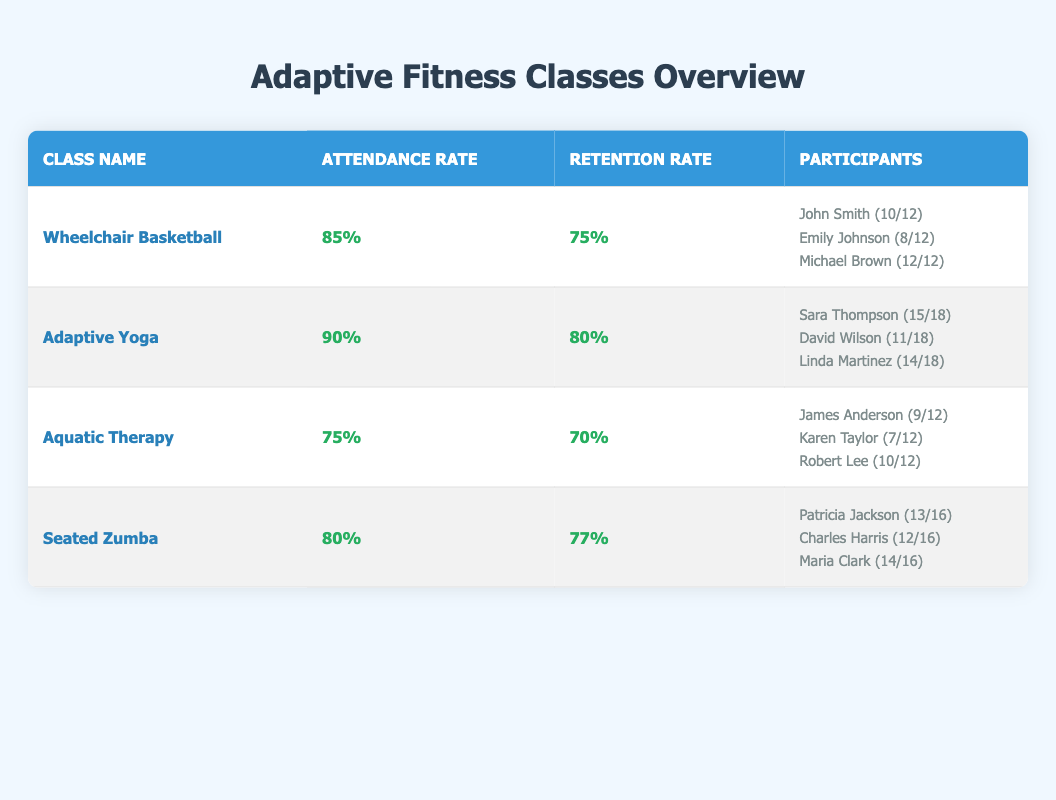What is the attendance rate for Adaptive Yoga? The attendance rate for Adaptive Yoga is listed directly in the table, which shows 90% under Attendance Rate for this class.
Answer: 90% Which class has the highest retention rate? Comparing the retention rates of all the classes, Adaptive Yoga has a retention rate of 80%, which is the highest when compared to the others: Wheelchair Basketball (75%), Aquatic Therapy (70%), and Seated Zumba (77%).
Answer: Adaptive Yoga How many participants attended all sessions in Wheelchair Basketball? In the Wheelchair Basketball class, Michael Brown attended all 12 sessions. This is the only participant specifically noted for having perfect attendance in the provided data.
Answer: 1 What is the average attendance rate across all classes? To find the average attendance rate, add the attendance rates (85 + 90 + 75 + 80) = 330, and then divide by the number of classes (4). Therefore, the average is 330/4 = 82.5%.
Answer: 82.5% Did any class have a lower retention rate than its attendance rate? By comparing the attendance rates and retention rates: Wheelchair Basketball (85/75), Adaptive Yoga (90/80), Aquatic Therapy (75/70), and Seated Zumba (80/77), we can see that both Aquatic Therapy and Wheelchair Basketball had lower retention rates than their attendance rates.
Answer: Yes What is the total number of sessions attended by all participants in Seated Zumba? In Seated Zumba, the sessions attended are: Patricia Jackson (13), Charles Harris (12), Maria Clark (14). Summing these gives 13 + 12 + 14 = 39 total sessions attended.
Answer: 39 How many total sessions were planned for participants in Adaptive Yoga? The total number of sessions for participants in Adaptive Yoga is reported as 18 for each participant in the table, and since there are three participants, the planned sessions do not add up but rather remain the same at 18, regardless of participant counts.
Answer: 18 Which participant had the lowest attendance in Aquatic Therapy? Among participants in Aquatic Therapy, James Anderson attended 9 sessions, Karen Taylor attended 7 sessions, and Robert Lee attended 10 sessions. Thus, Karen Taylor is noted as the one with the lowest attendance.
Answer: Karen Taylor Is the attendance rate for Wheelchair Basketball higher than that for Aquatic Therapy? The attendance rate for Wheelchair Basketball is 85%, while Aquatic Therapy's attendance rate is 75%. Since 85% is greater than 75%, the conclusion is clear regarding attendance performance between these two classes.
Answer: Yes 